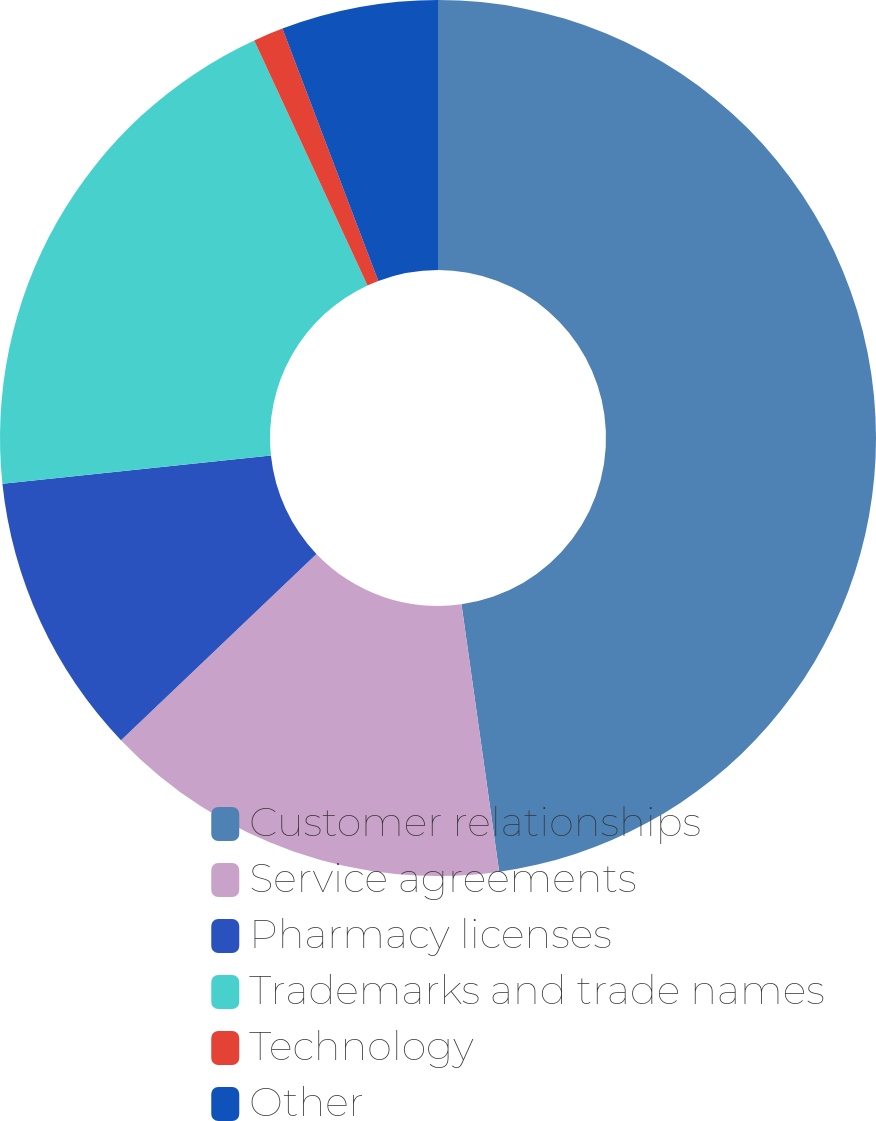<chart> <loc_0><loc_0><loc_500><loc_500><pie_chart><fcel>Customer relationships<fcel>Service agreements<fcel>Pharmacy licenses<fcel>Trademarks and trade names<fcel>Technology<fcel>Other<nl><fcel>47.77%<fcel>15.11%<fcel>10.45%<fcel>19.78%<fcel>1.11%<fcel>5.78%<nl></chart> 